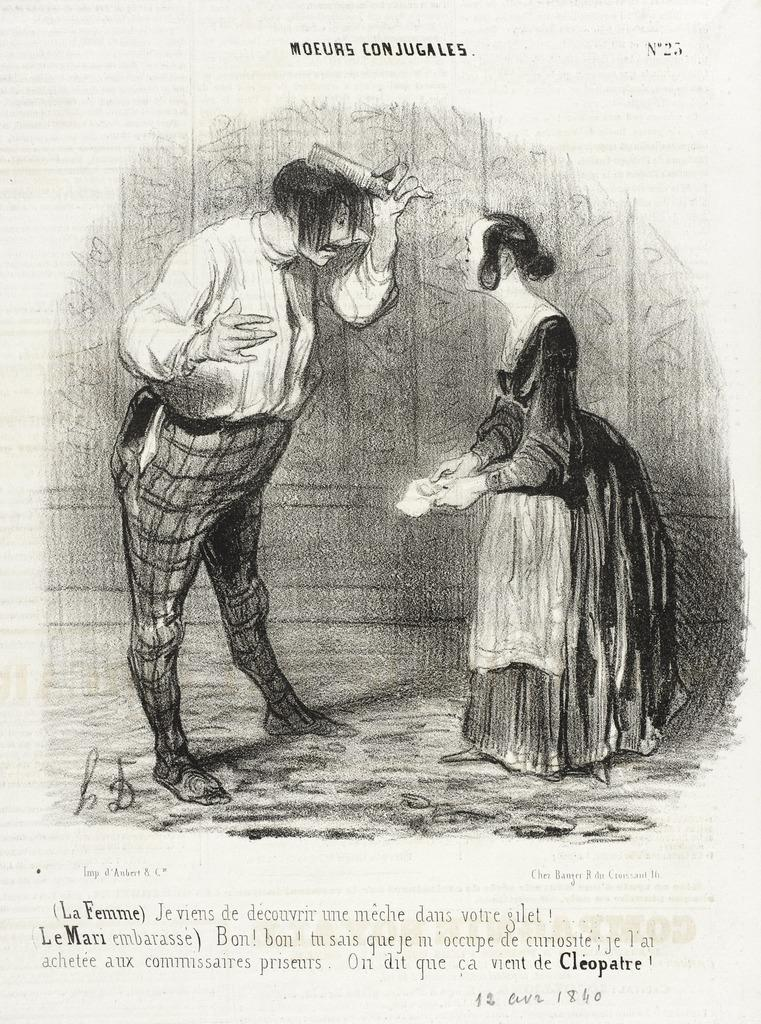What is depicted in the center of the image? There is a drawing of a man and a drawing of a woman in the center of the image. What can be found at the top and bottom of the image? There is text at the top and bottom of the image. How does the image depict the level of pollution in the scene? The image does not depict any pollution or scene; it only contains drawings of a man and a woman with text at the top and bottom. 